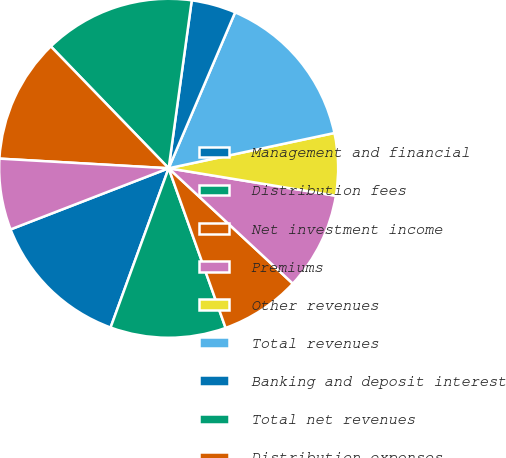Convert chart. <chart><loc_0><loc_0><loc_500><loc_500><pie_chart><fcel>Management and financial<fcel>Distribution fees<fcel>Net investment income<fcel>Premiums<fcel>Other revenues<fcel>Total revenues<fcel>Banking and deposit interest<fcel>Total net revenues<fcel>Distribution expenses<fcel>Interest credited to fixed<nl><fcel>13.56%<fcel>11.02%<fcel>7.63%<fcel>9.32%<fcel>5.93%<fcel>15.25%<fcel>4.24%<fcel>14.41%<fcel>11.86%<fcel>6.78%<nl></chart> 